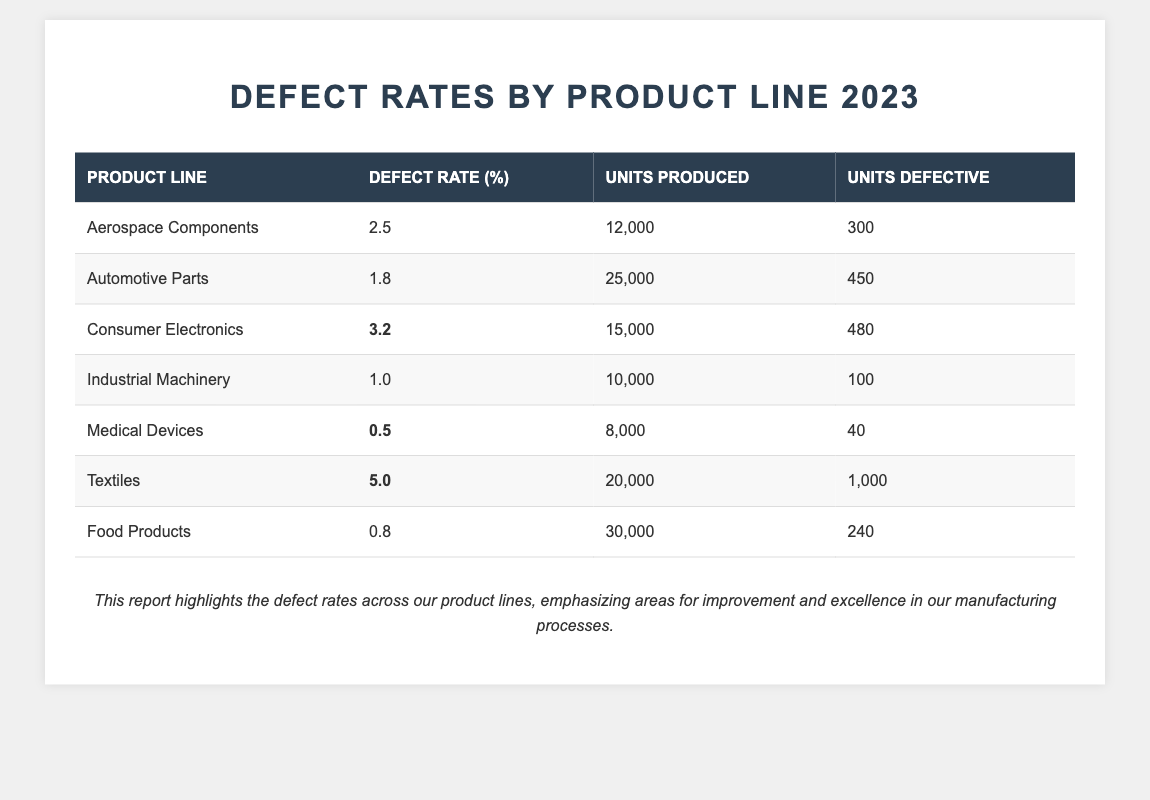What is the defect rate for Medical Devices? The defect rate for Medical Devices is listed directly in the table under the "Defect Rate (%)" column. It shows a value of 0.5%.
Answer: 0.5% Which product line has the highest defect rate? By comparing the values in the "Defect Rate (%)" column, Textiles has the highest defect rate at 5.0%.
Answer: Textiles How many units were produced for Automotive Parts? The number of units produced for Automotive Parts is indicated in the "Units Produced" column, which shows a total of 25,000 units.
Answer: 25,000 What is the total number of defective units across all product lines? To find the total number of defective units, sum the "Units Defective" values for all product lines: 300 + 450 + 480 + 100 + 40 + 1000 + 240 = 2610.
Answer: 2610 What is the average defect rate across all product lines? The average defect rate is calculated by summing all defect rates (2.5 + 1.8 + 3.2 + 1.0 + 0.5 + 5.0 + 0.8) = 15.8, then dividing by the number of product lines (7): 15.8 / 7 ≈ 2.26.
Answer: 2.26 Are there more units defective in Consumer Electronics than in Medical Devices? Compare the "Units Defective" for both product lines: Consumer Electronics has 480 units defective while Medical Devices has 40. Since 480 is greater than 40, the statement is true.
Answer: Yes What is the difference in defect rates between the highest and lowest product lines? The highest defect rate is for Textiles at 5.0% and the lowest is for Medical Devices at 0.5%. The difference is 5.0 - 0.5 = 4.5%.
Answer: 4.5% How many units were produced in total across all product lines? To find the total units produced, sum the "Units Produced" values: 12000 + 25000 + 15000 + 10000 + 8000 + 20000 + 30000 = 115000.
Answer: 115000 Is there any product line with a defect rate below 1%? The defect rates for Medical Devices (0.5%) and Food Products (0.8%) are both below 1%. Therefore, there are product lines with defect rates below 1%.
Answer: Yes What percentage of units produced for Textiles were defective? Calculate the defective percentage by dividing the number of defective units (1000) by the total units produced (20000) and multiplying by 100: (1000 / 20000) * 100 = 5%.
Answer: 5% 